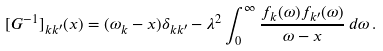Convert formula to latex. <formula><loc_0><loc_0><loc_500><loc_500>[ G ^ { - 1 } ] _ { k k ^ { \prime } } ( x ) = ( \omega _ { k } - x ) \delta _ { k k ^ { \prime } } - \lambda ^ { 2 } \int _ { 0 } ^ { \infty } \frac { f _ { k } ( \omega ) f _ { k ^ { \prime } } ( \omega ) } { \omega - x } \, d \omega \, .</formula> 